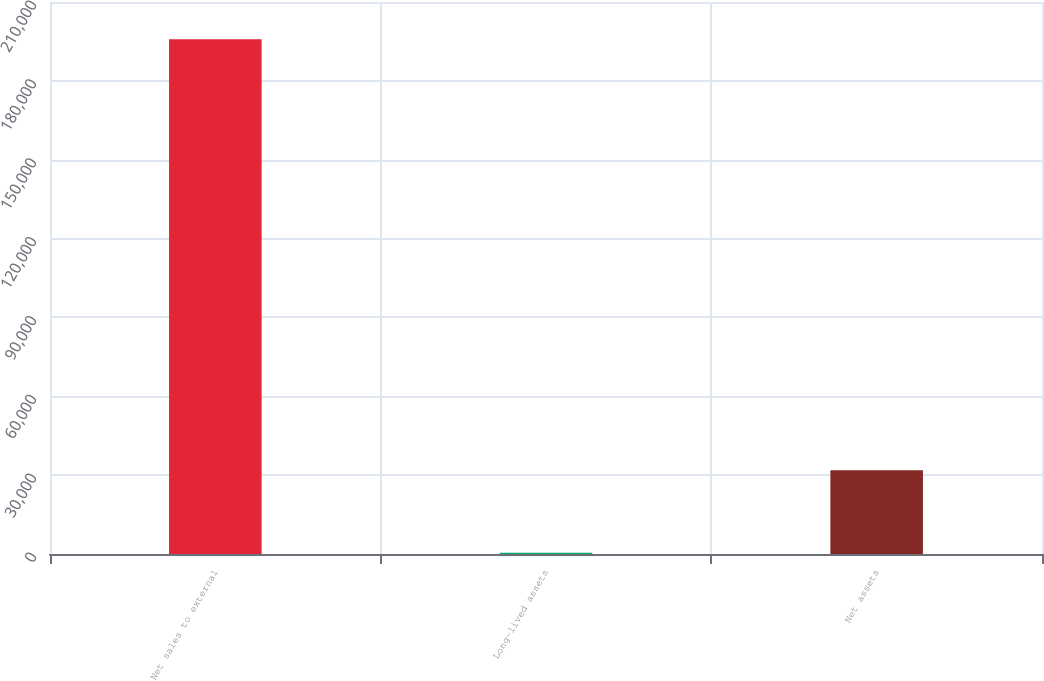Convert chart. <chart><loc_0><loc_0><loc_500><loc_500><bar_chart><fcel>Net sales to external<fcel>Long-lived assets<fcel>Net assets<nl><fcel>195863<fcel>457<fcel>31874<nl></chart> 